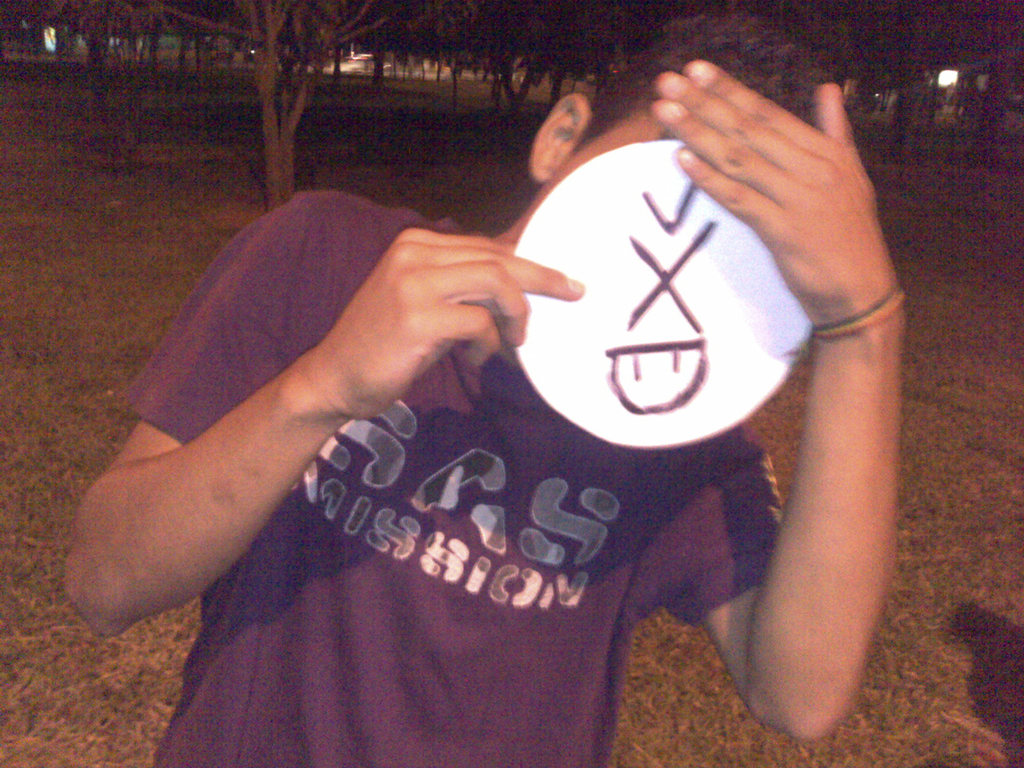What does the text on the mask mean, and how might it relate to the person's expression? The text 'SAD' upside down could signify a playful take on emotions, contrasting with the person's hidden face which adds an element of mystery and fun to their expression. 